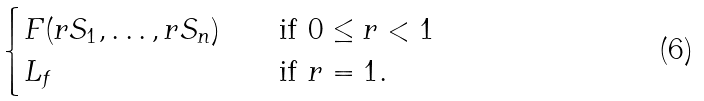<formula> <loc_0><loc_0><loc_500><loc_500>\begin{cases} F ( r S _ { 1 } , \dots , r S _ { n } ) & \quad \text {if } 0 \leq r < 1 \\ L _ { f } & \quad \text {if } r = 1 . \end{cases}</formula> 